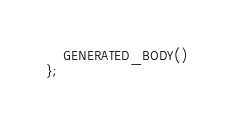Convert code to text. <code><loc_0><loc_0><loc_500><loc_500><_C_>	GENERATED_BODY()
};
</code> 